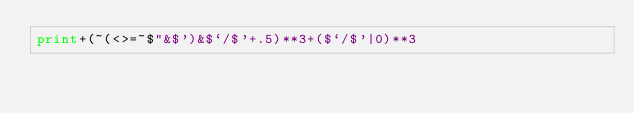Convert code to text. <code><loc_0><loc_0><loc_500><loc_500><_Perl_>print+(~(<>=~$"&$')&$`/$'+.5)**3+($`/$'|0)**3</code> 